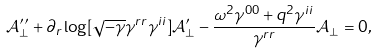Convert formula to latex. <formula><loc_0><loc_0><loc_500><loc_500>\mathcal { A } _ { \perp } ^ { \prime \prime } + \partial _ { r } \log [ \sqrt { - \gamma } \gamma ^ { r r } \gamma ^ { i i } ] \mathcal { A } _ { \perp } ^ { \prime } - \frac { \omega ^ { 2 } \gamma ^ { 0 0 } + q ^ { 2 } \gamma ^ { i i } } { \gamma ^ { r r } } \mathcal { A } _ { \perp } = 0 ,</formula> 